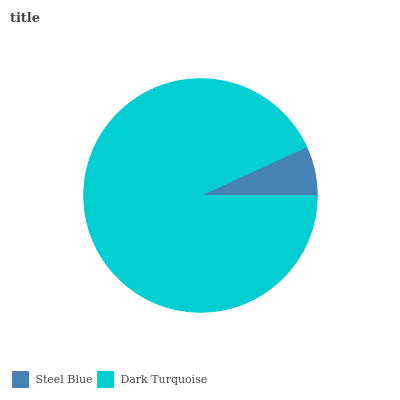Is Steel Blue the minimum?
Answer yes or no. Yes. Is Dark Turquoise the maximum?
Answer yes or no. Yes. Is Dark Turquoise the minimum?
Answer yes or no. No. Is Dark Turquoise greater than Steel Blue?
Answer yes or no. Yes. Is Steel Blue less than Dark Turquoise?
Answer yes or no. Yes. Is Steel Blue greater than Dark Turquoise?
Answer yes or no. No. Is Dark Turquoise less than Steel Blue?
Answer yes or no. No. Is Dark Turquoise the high median?
Answer yes or no. Yes. Is Steel Blue the low median?
Answer yes or no. Yes. Is Steel Blue the high median?
Answer yes or no. No. Is Dark Turquoise the low median?
Answer yes or no. No. 